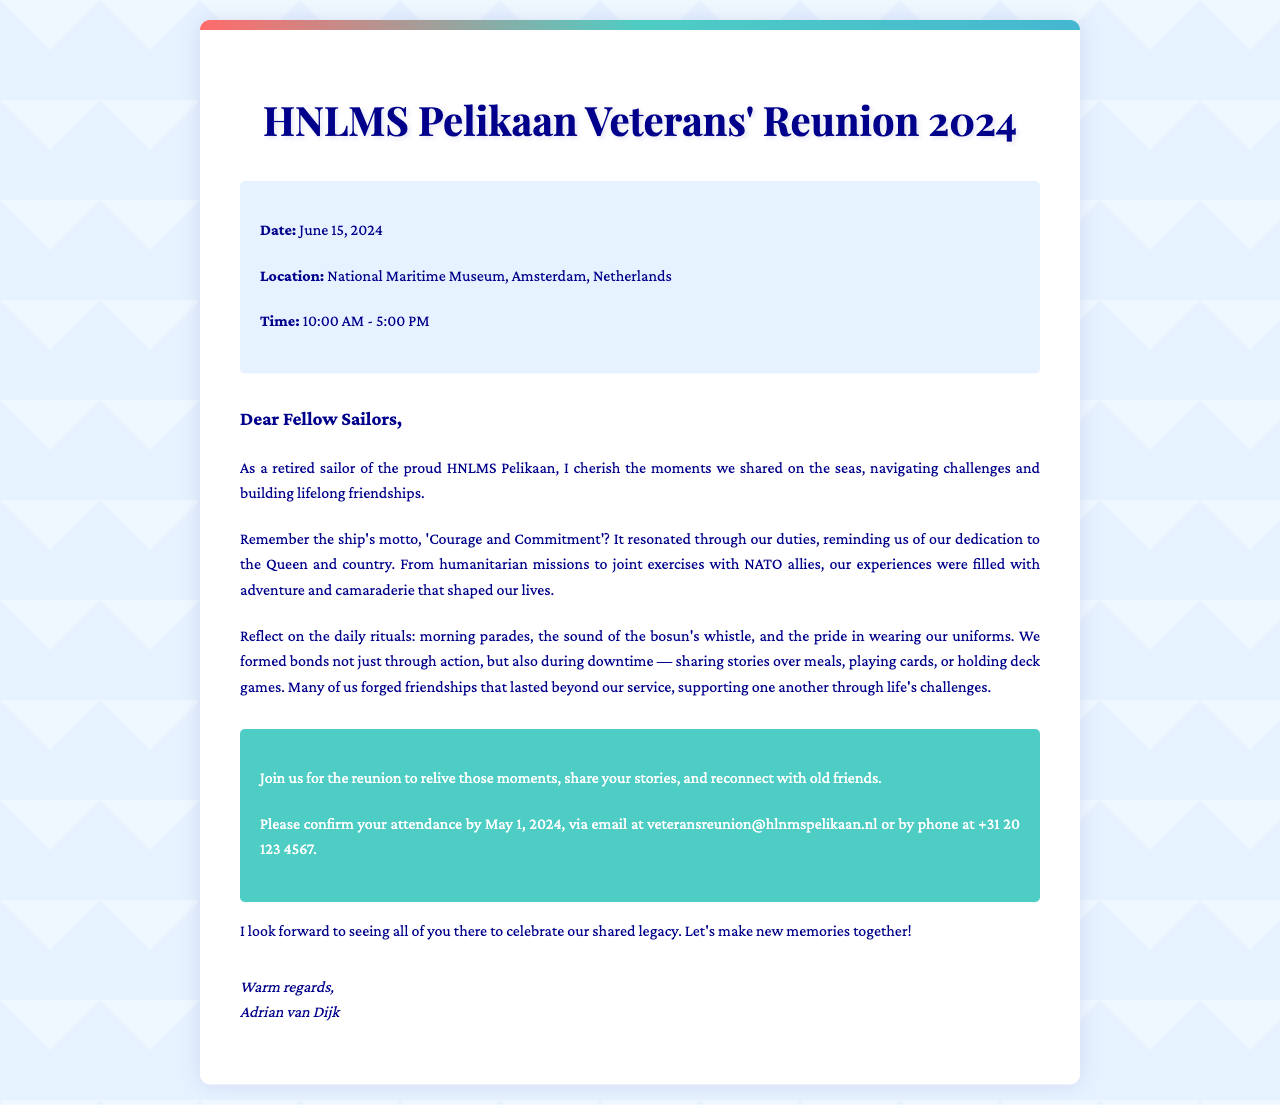what is the date of the reunion? The date of the reunion is explicitly mentioned at the beginning of the document.
Answer: June 15, 2024 where is the reunion being held? The location of the reunion is stated clearly in the event details section.
Answer: National Maritime Museum, Amsterdam, Netherlands what time does the reunion start? The start time of the reunion is provided in the document along with the end time.
Answer: 10:00 AM who is the sender of the letter? The sender of the letter is identified in the signature section at the end of the document.
Answer: Adrian van Dijk what was the motto of the ship? The motto of the ship is mentioned in the context of what it meant to the sailors.
Answer: Courage and Commitment how should attendees confirm their attendance? The method of confirming attendance is outlined towards the end of the document.
Answer: via email or phone what is a common activity mentioned that sailors did during downtime? The document lists several activities sailors engaged in during leisure times.
Answer: sharing stories over meals what is the response deadline for confirming attendance? The deadline for responses is specified in the call-to-action section of the document.
Answer: May 1, 2024 what is the purpose of the reunion mentioned in the letter? The purpose of the reunion is explained in several phrases throughout the document.
Answer: to relive those moments and reconnect with old friends 